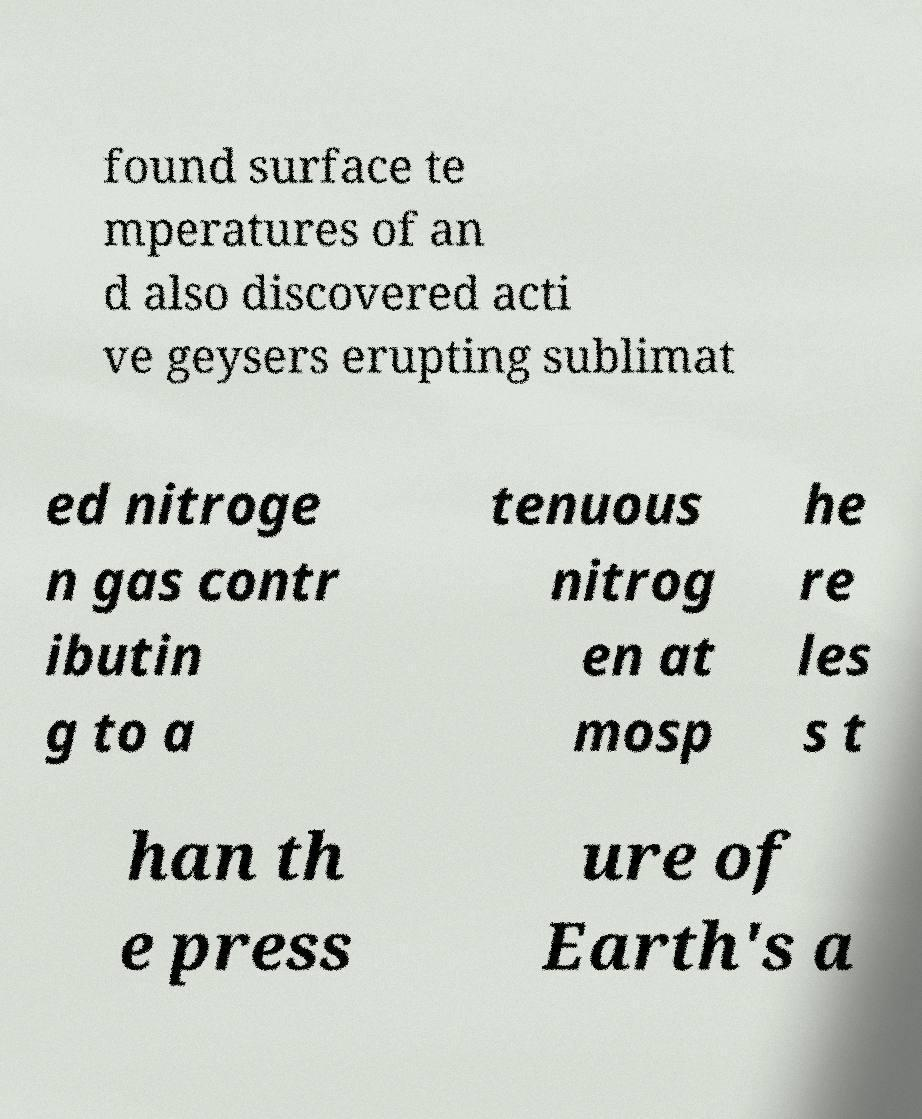For documentation purposes, I need the text within this image transcribed. Could you provide that? found surface te mperatures of an d also discovered acti ve geysers erupting sublimat ed nitroge n gas contr ibutin g to a tenuous nitrog en at mosp he re les s t han th e press ure of Earth's a 